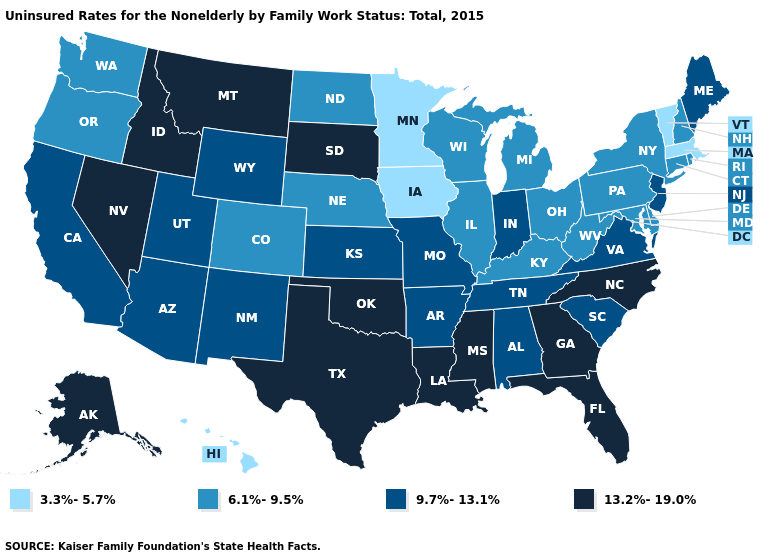What is the value of Missouri?
Answer briefly. 9.7%-13.1%. What is the highest value in the USA?
Keep it brief. 13.2%-19.0%. Is the legend a continuous bar?
Keep it brief. No. Which states have the lowest value in the South?
Write a very short answer. Delaware, Kentucky, Maryland, West Virginia. Among the states that border Kentucky , which have the highest value?
Quick response, please. Indiana, Missouri, Tennessee, Virginia. What is the value of Wisconsin?
Give a very brief answer. 6.1%-9.5%. Name the states that have a value in the range 3.3%-5.7%?
Keep it brief. Hawaii, Iowa, Massachusetts, Minnesota, Vermont. Which states have the lowest value in the USA?
Answer briefly. Hawaii, Iowa, Massachusetts, Minnesota, Vermont. Does Washington have the same value as Maryland?
Give a very brief answer. Yes. What is the lowest value in the South?
Short answer required. 6.1%-9.5%. What is the value of Arkansas?
Give a very brief answer. 9.7%-13.1%. Among the states that border California , does Arizona have the lowest value?
Answer briefly. No. Does the first symbol in the legend represent the smallest category?
Concise answer only. Yes. Does the first symbol in the legend represent the smallest category?
Answer briefly. Yes. Name the states that have a value in the range 9.7%-13.1%?
Give a very brief answer. Alabama, Arizona, Arkansas, California, Indiana, Kansas, Maine, Missouri, New Jersey, New Mexico, South Carolina, Tennessee, Utah, Virginia, Wyoming. 